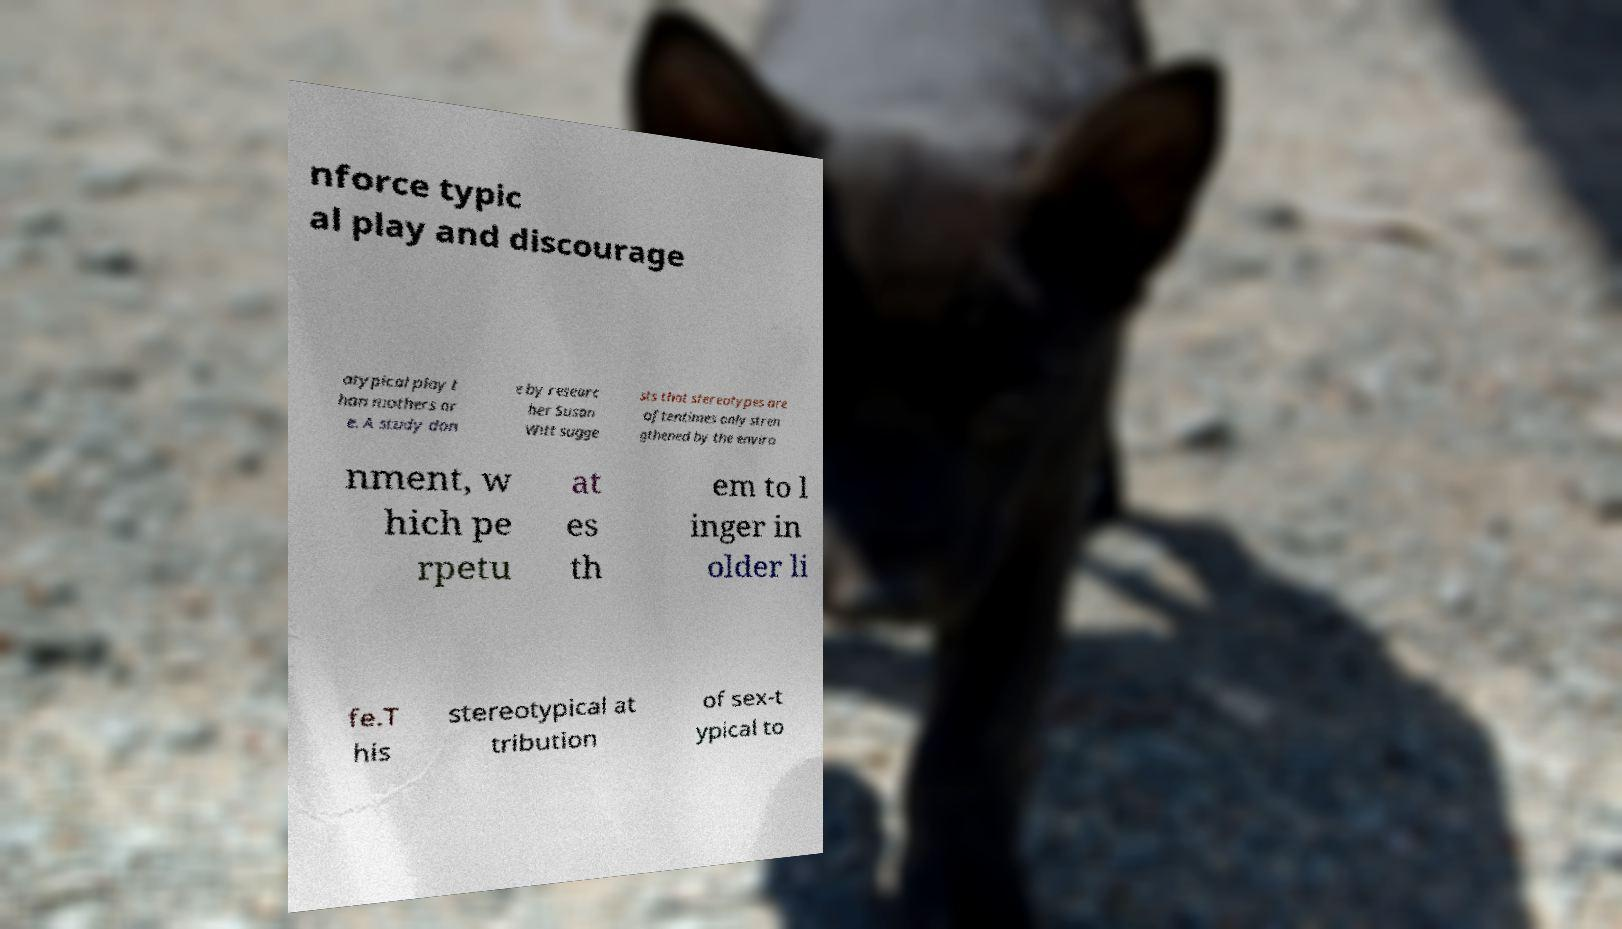Could you extract and type out the text from this image? nforce typic al play and discourage atypical play t han mothers ar e. A study don e by researc her Susan Witt sugge sts that stereotypes are oftentimes only stren gthened by the enviro nment, w hich pe rpetu at es th em to l inger in older li fe.T his stereotypical at tribution of sex-t ypical to 